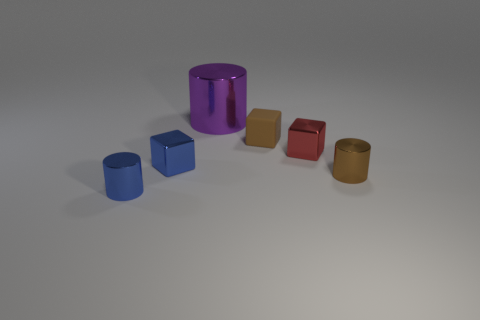What is the shape of the small red thing that is in front of the purple shiny cylinder?
Provide a succinct answer. Cube. Are there any brown shiny objects that are to the right of the tiny cylinder that is to the right of the cylinder that is left of the large metal cylinder?
Provide a short and direct response. No. There is a small brown thing that is the same shape as the purple thing; what is it made of?
Your response must be concise. Metal. Is there anything else that has the same material as the purple thing?
Provide a short and direct response. Yes. How many blocks are small blue things or tiny metallic objects?
Make the answer very short. 2. There is a cylinder behind the brown shiny cylinder; is it the same size as the object that is right of the small red cube?
Your answer should be compact. No. There is a cube that is to the left of the brown thing behind the small red metal block; what is its material?
Offer a terse response. Metal. Is the number of rubber blocks that are on the left side of the blue cylinder less than the number of blue cylinders?
Provide a succinct answer. Yes. There is a red object that is made of the same material as the purple cylinder; what shape is it?
Your answer should be very brief. Cube. How many other things are there of the same shape as the small matte thing?
Keep it short and to the point. 2. 